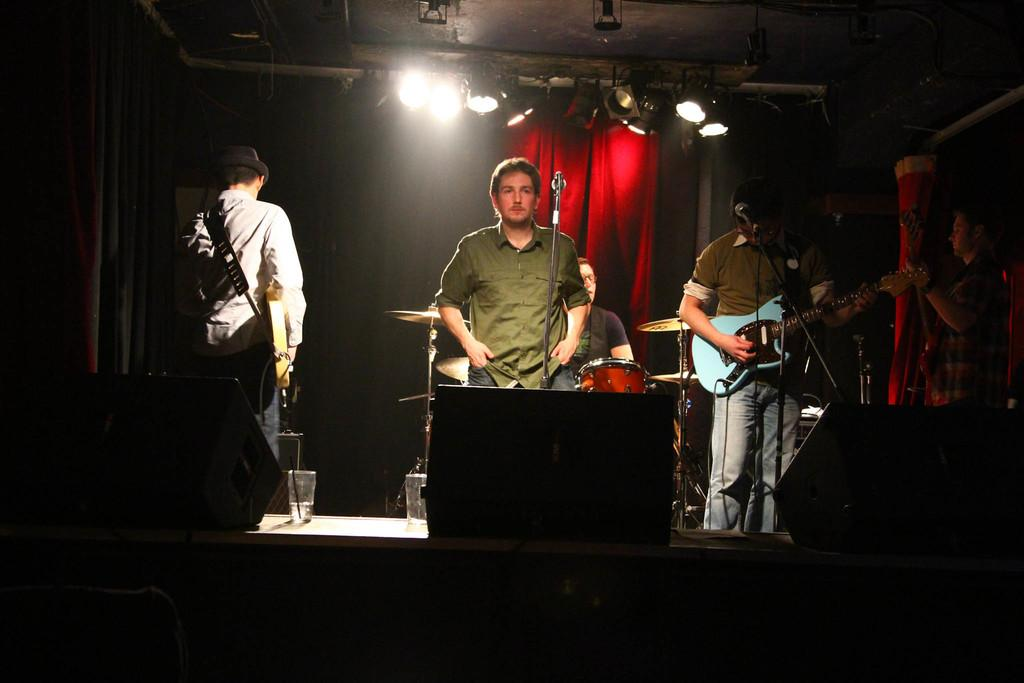What are the two men in the image doing? The two men are standing in front of a microphone. How many people are playing guitar in the image? There are three people playing guitar in the image. What type of twig is being used as a guitar pick by one of the guitar players? There is no twig visible in the image, and it is not mentioned that any of the guitar players are using a twig as a guitar pick. 